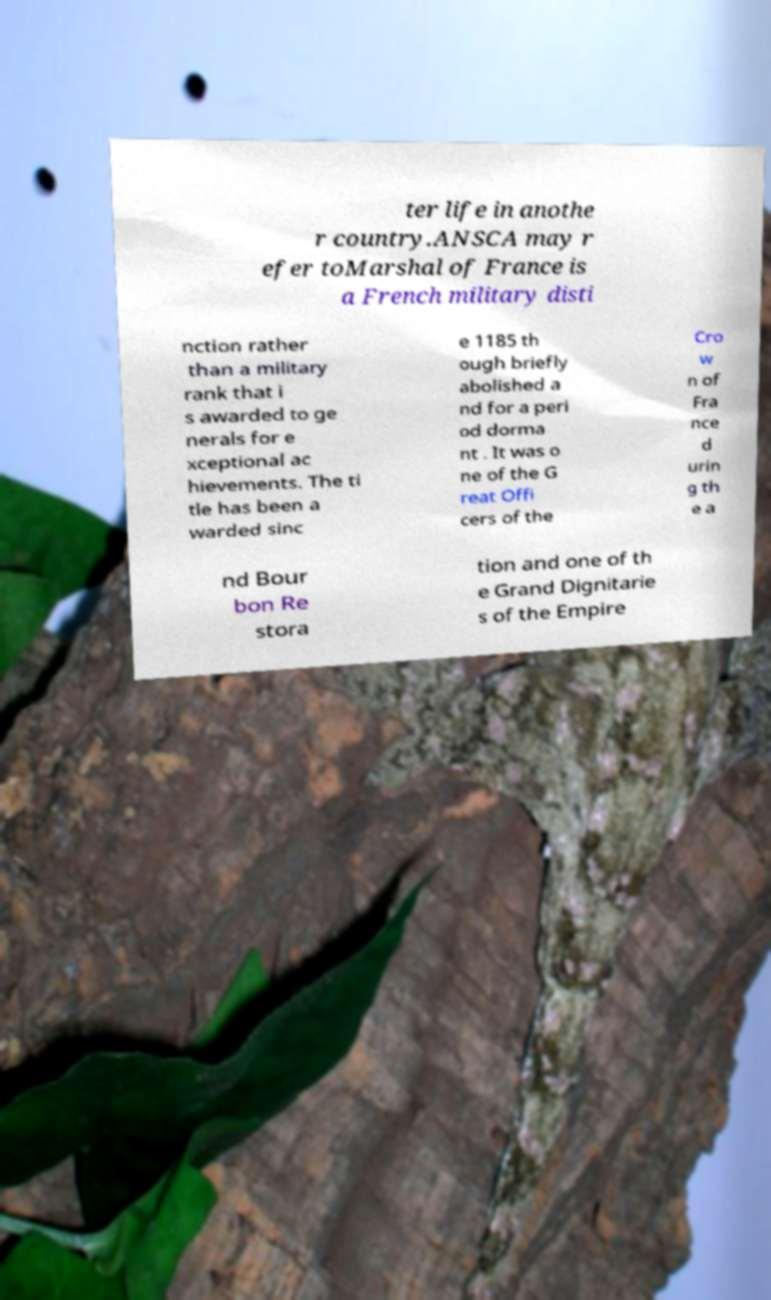I need the written content from this picture converted into text. Can you do that? ter life in anothe r country.ANSCA may r efer toMarshal of France is a French military disti nction rather than a military rank that i s awarded to ge nerals for e xceptional ac hievements. The ti tle has been a warded sinc e 1185 th ough briefly abolished a nd for a peri od dorma nt . It was o ne of the G reat Offi cers of the Cro w n of Fra nce d urin g th e a nd Bour bon Re stora tion and one of th e Grand Dignitarie s of the Empire 